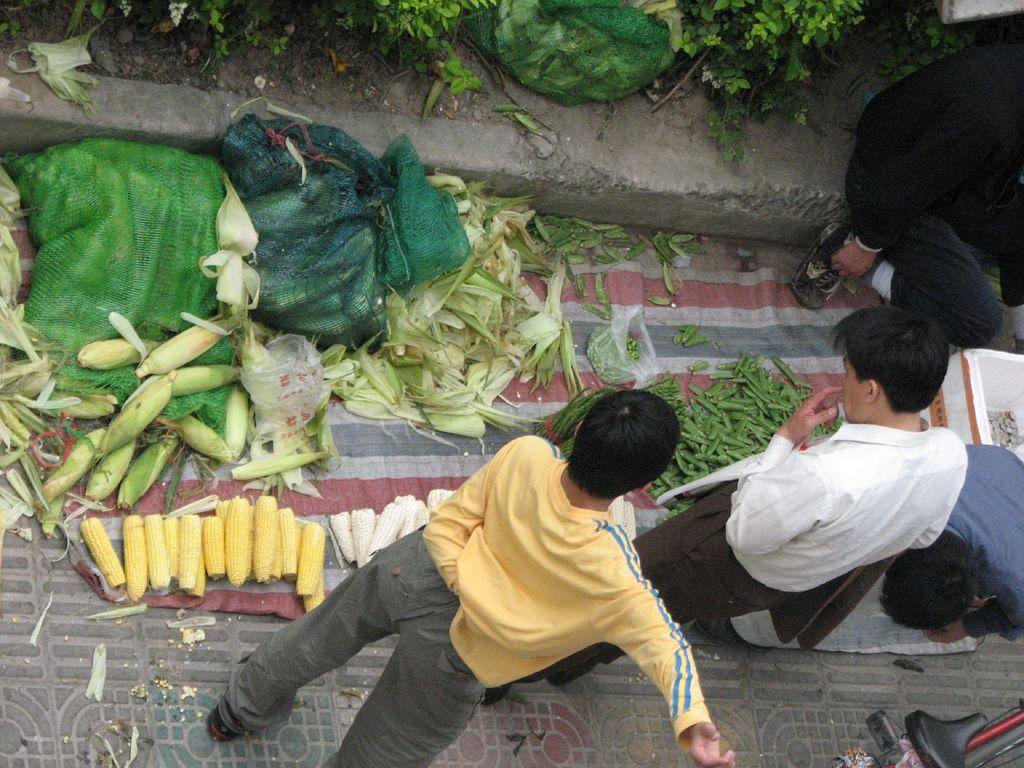What is happening in the image? There are people standing in the image. Can you describe the green color food item on the ground? There is a green color food item on the ground in the image. What thought is being shared among the group in the image? There is no indication of a shared thought among the group in the image, as we cannot see their facial expressions or hear any conversation. 